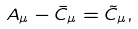Convert formula to latex. <formula><loc_0><loc_0><loc_500><loc_500>A _ { \mu } - \bar { C } _ { \mu } = \tilde { C } _ { \mu } ,</formula> 